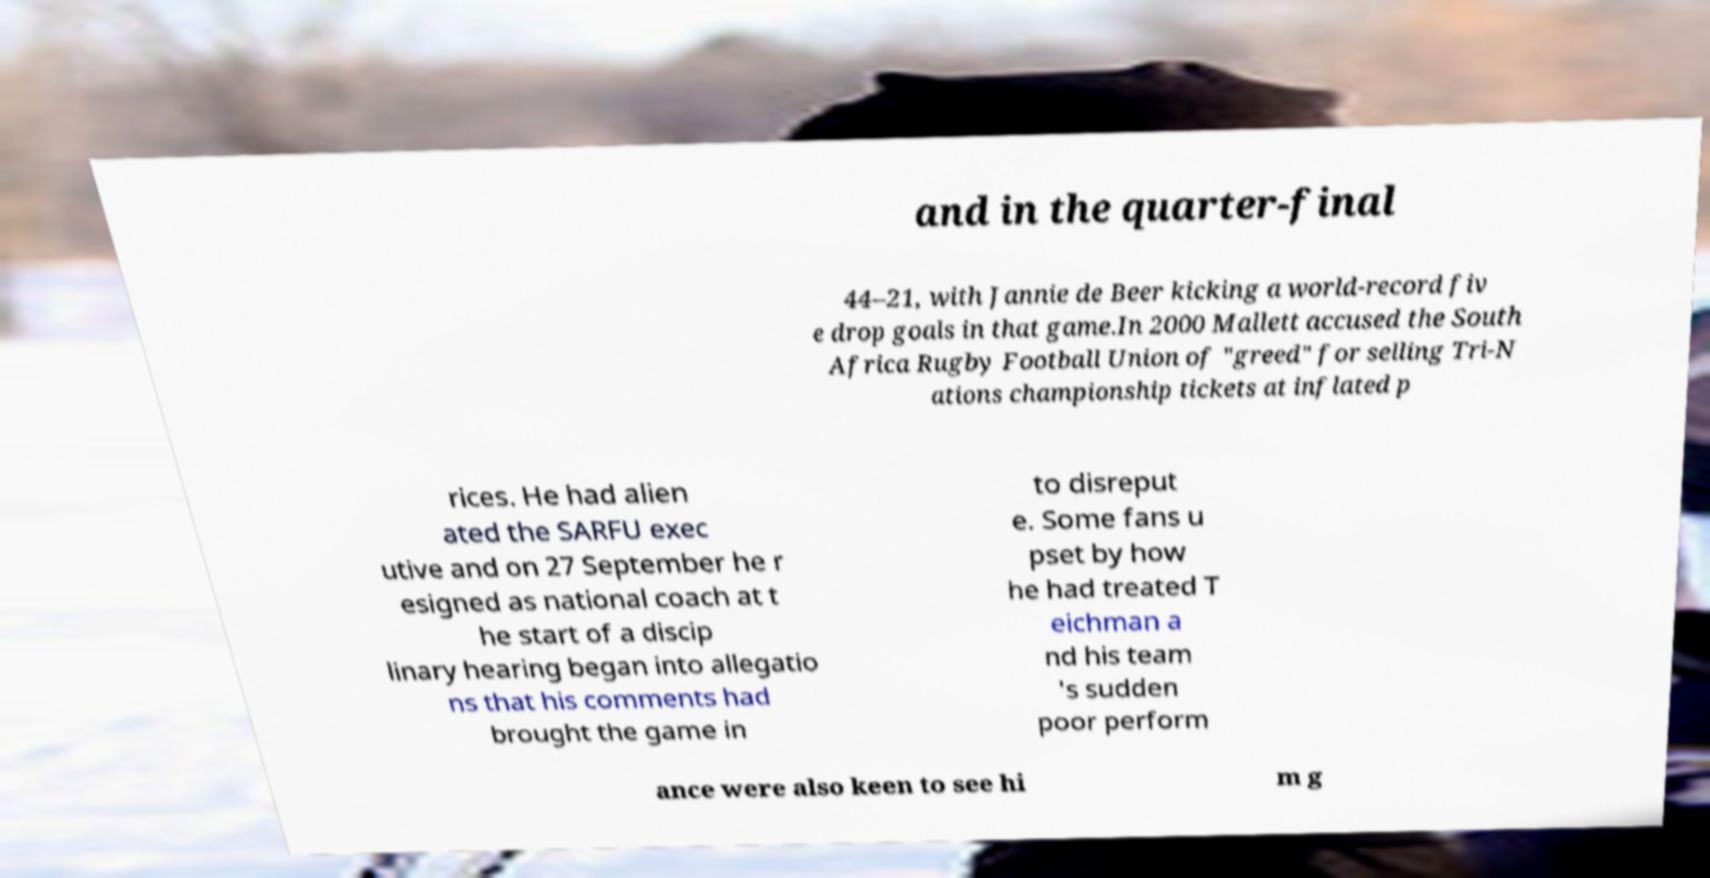Please identify and transcribe the text found in this image. and in the quarter-final 44–21, with Jannie de Beer kicking a world-record fiv e drop goals in that game.In 2000 Mallett accused the South Africa Rugby Football Union of "greed" for selling Tri-N ations championship tickets at inflated p rices. He had alien ated the SARFU exec utive and on 27 September he r esigned as national coach at t he start of a discip linary hearing began into allegatio ns that his comments had brought the game in to disreput e. Some fans u pset by how he had treated T eichman a nd his team 's sudden poor perform ance were also keen to see hi m g 